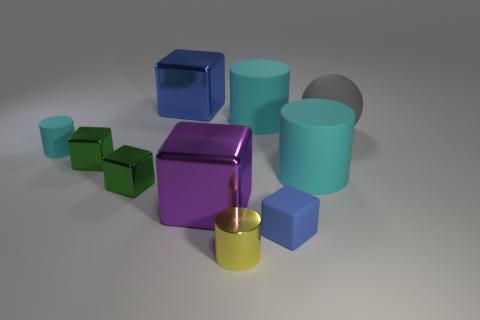What number of other objects are the same material as the purple thing? If we look closely at the glossy reflection and smooth surfaces, it suggests that the purple cube is made of a metallic material. There are two other cubes, one cylinder, and one short column that appear to share the same metallic characteristics, making the answer 4. 